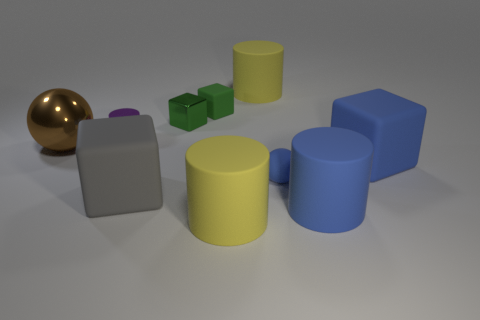What number of big yellow cylinders are the same material as the small blue thing?
Ensure brevity in your answer.  2. The big metallic sphere is what color?
Provide a short and direct response. Brown. There is a yellow rubber thing behind the tiny sphere; is its shape the same as the big yellow object in front of the brown metallic sphere?
Your response must be concise. Yes. The large matte cube that is behind the small ball is what color?
Offer a very short reply. Blue. Are there fewer tiny green things that are in front of the tiny ball than large brown metallic things to the right of the large blue cylinder?
Keep it short and to the point. No. How many other things are there of the same material as the large blue block?
Ensure brevity in your answer.  6. Are the blue block and the large blue cylinder made of the same material?
Keep it short and to the point. Yes. What number of other objects are there of the same size as the green metal block?
Your answer should be compact. 3. What size is the yellow cylinder in front of the yellow cylinder behind the purple metal cylinder?
Offer a very short reply. Large. The large block to the left of the small rubber object to the right of the big yellow rubber thing behind the big metallic sphere is what color?
Keep it short and to the point. Gray. 